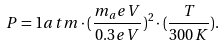<formula> <loc_0><loc_0><loc_500><loc_500>P = 1 a t m \cdot ( \frac { m _ { a } e V } { 0 . 3 e V } ) ^ { 2 } \cdot ( \frac { T } { 3 0 0 K } ) .</formula> 